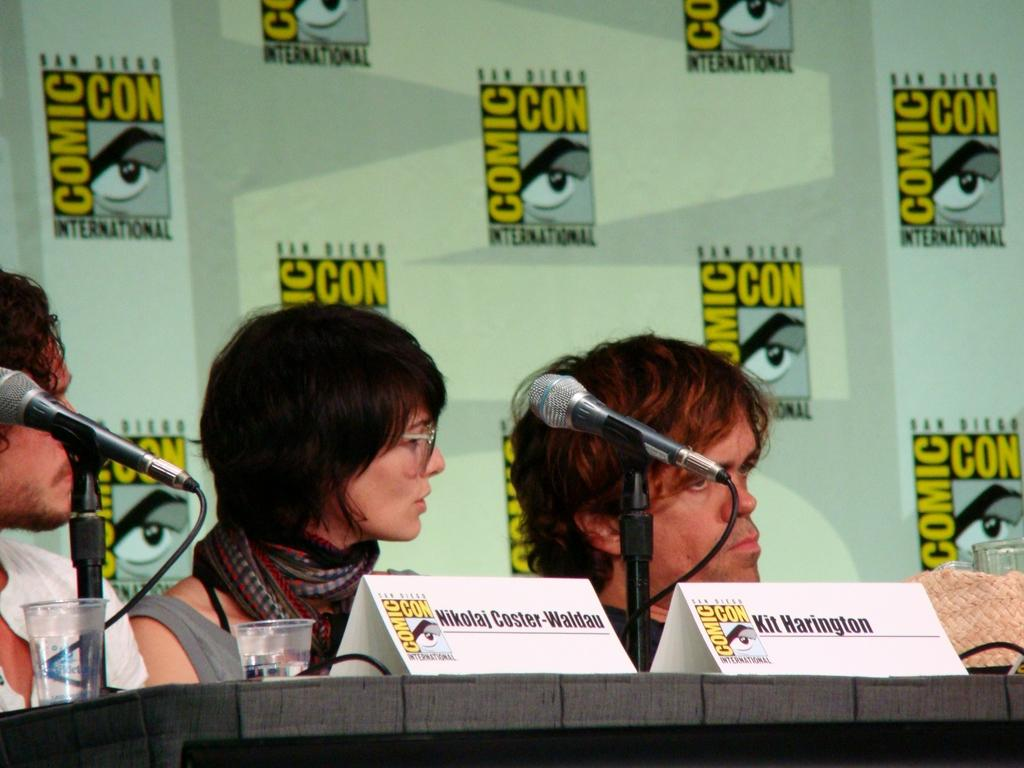Who or what can be seen in the image? There are people in the image. What objects are present that might be used for amplifying sound? There are microphones (mics) in the image. What structures are visible that might be used for holding or displaying items? There are stands in the image. What objects are present that might be used for drinking? There are glasses in the image. What objects are present that might be used for writing or displaying information? There are boards in the image. Are there any other objects present that are not specified? Yes, there are unspecified objects in the image. What structures are attached to the wall in the image? There are posts attached to the wall in the image. What type of amusement can be seen in the image? There is no amusement present in the image; it features people, microphones, stands, glasses, boards, unspecified objects, and posts attached to the wall. What type of approval is being given by the people in the image? There is no indication of approval or disapproval in the image; it simply shows people, microphones, stands, glasses, boards, unspecified objects, and posts attached to the wall. 